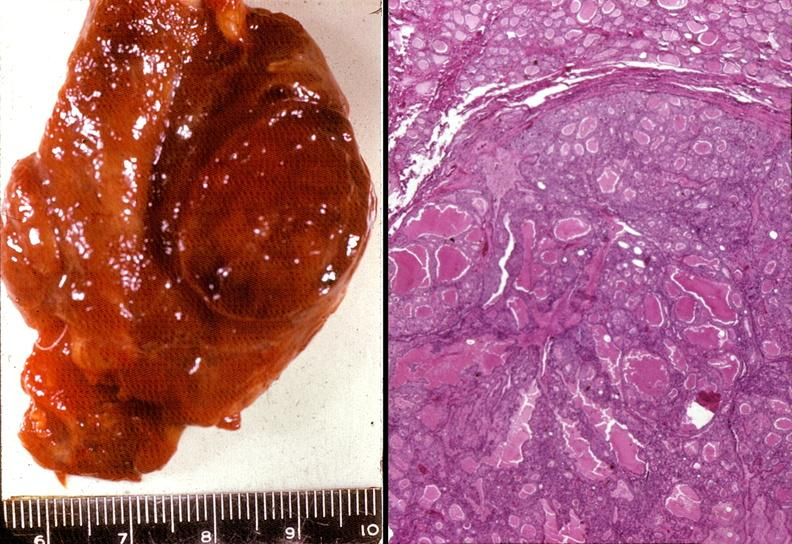s polycystic disease present?
Answer the question using a single word or phrase. No 